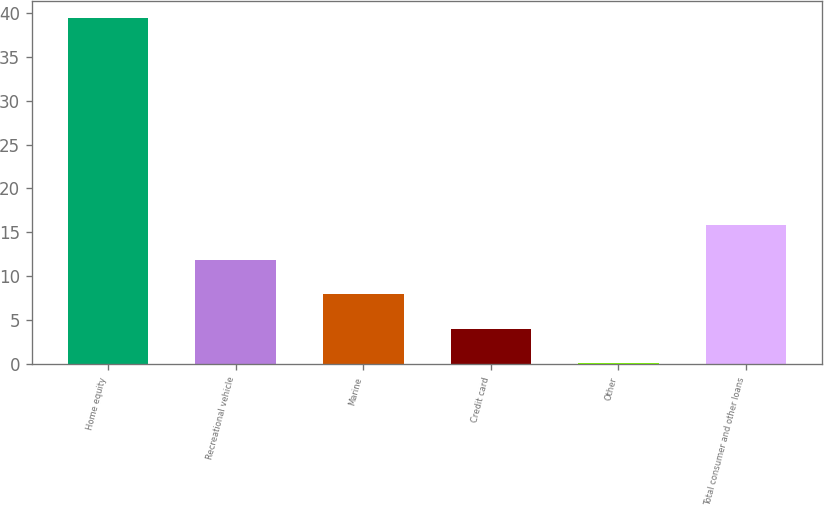<chart> <loc_0><loc_0><loc_500><loc_500><bar_chart><fcel>Home equity<fcel>Recreational vehicle<fcel>Marine<fcel>Credit card<fcel>Other<fcel>Total consumer and other loans<nl><fcel>39.4<fcel>11.89<fcel>7.96<fcel>4.03<fcel>0.1<fcel>15.82<nl></chart> 